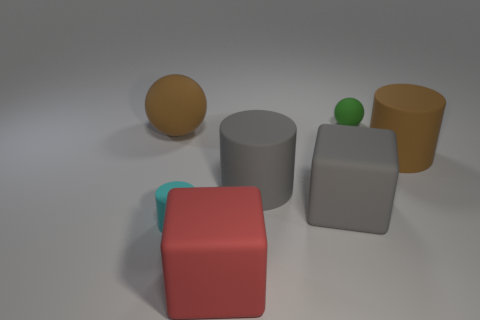What number of brown things are either large matte blocks or small rubber balls?
Provide a short and direct response. 0. The tiny matte sphere is what color?
Keep it short and to the point. Green. What is the size of the other sphere that is made of the same material as the large brown sphere?
Your answer should be very brief. Small. How many other objects are the same shape as the red thing?
Provide a short and direct response. 1. Are there any other things that are the same size as the gray matte cylinder?
Make the answer very short. Yes. There is a gray block that is behind the large red thing that is in front of the cyan rubber object; how big is it?
Offer a terse response. Large. There is a sphere that is the same size as the cyan rubber cylinder; what is it made of?
Your answer should be compact. Rubber. Is there another tiny cyan object made of the same material as the cyan object?
Give a very brief answer. No. What color is the large matte cylinder that is on the right side of the sphere that is behind the big brown thing that is on the left side of the small cyan matte cylinder?
Provide a short and direct response. Brown. There is a rubber block that is to the left of the large gray rubber block; is its color the same as the matte thing that is on the right side of the small green object?
Your response must be concise. No. 